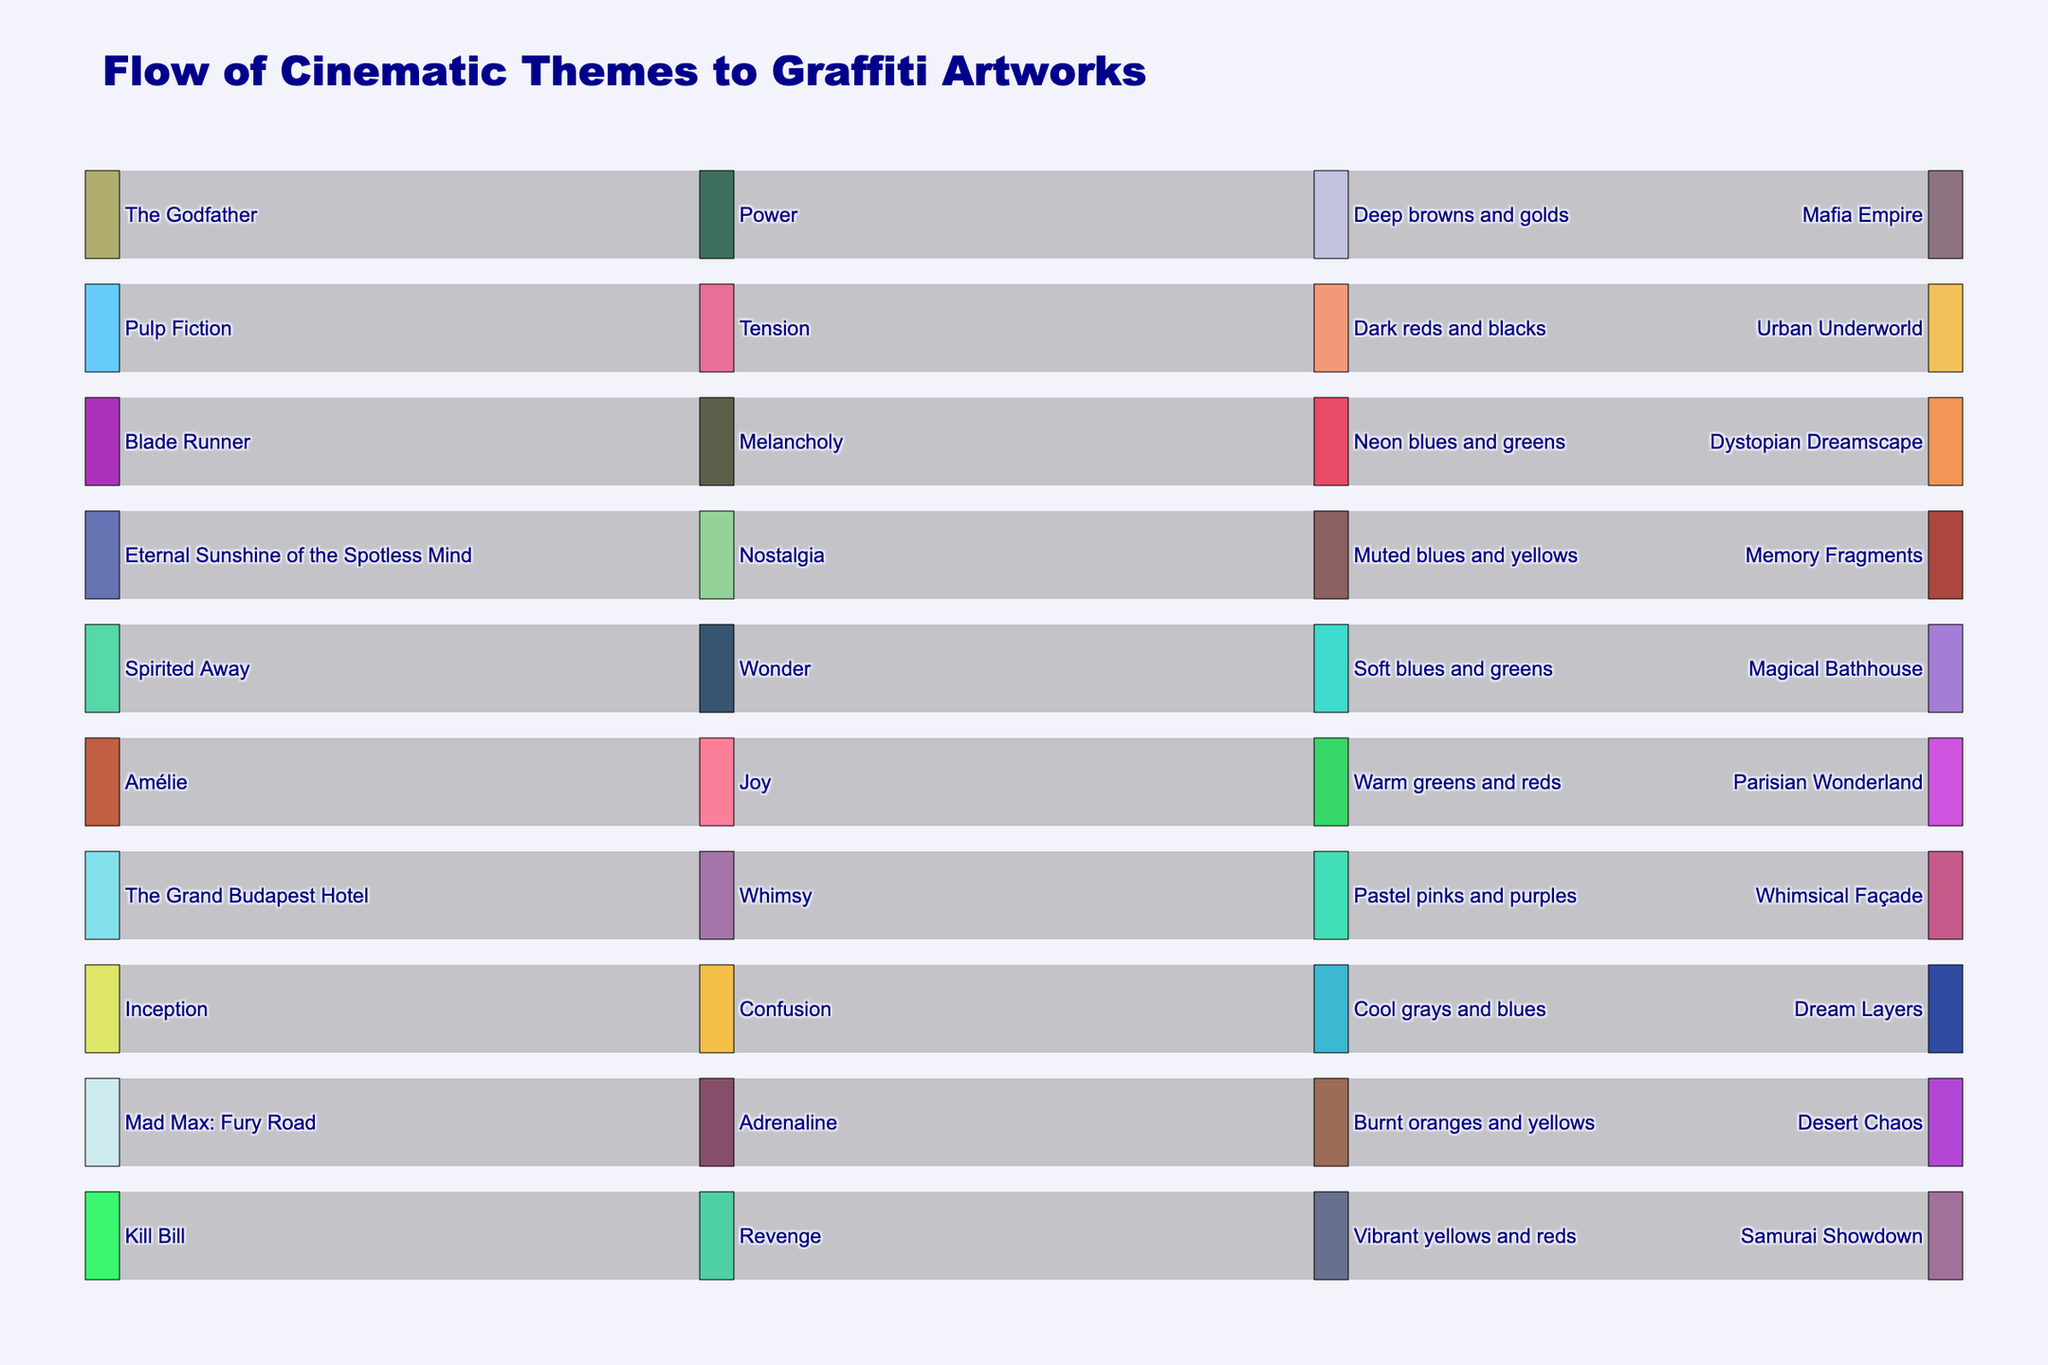Which movie's theme flows into the 'Desert Chaos' graffiti artwork? To determine which movie's theme flows into 'Desert Chaos,' follow the connection from the source movie names. 'Mad Max: Fury Road' flows into 'Adrenaline' and 'Burnt oranges and yellows' before reaching 'Desert Chaos'.
Answer: Mad Max: Fury Road What is the color palette for the graffiti artwork "Urban Underworld"? Trace the flow from the artwork 'Urban Underworld' backward. The color palette before it is 'Dark reds and blacks'.
Answer: Dark reds and blacks How many different emotions are represented in the Sankey diagram? To count the distinct emotions, list all the unique labels in the 'Emotion' category: Tension, Whimsy, Melancholy, Adrenaline, Joy, Power, Nostalgia, Wonder, Confusion, and Revenge, which totals to 10.
Answer: 10 Which movie evokes the emotion of 'Wonder'? Follow the connection from the emotion 'Wonder' backward to the source movie. 'Spirited Away' is linked to 'Wonder'.
Answer: Spirited Away Which color palettes are linked to emotions of 'Melancholy' and 'Joy'? Locate 'Melancholy' and 'Joy' and trace their connections to the color palettes. 'Melancholy' is connected to 'Neon blues and greens', and 'Joy' is connected to 'Warm greens and reds'.
Answer: Neon blues and greens and Warm greens and reds Which emotion eventually leads to the 'Memory Fragments' graffiti artwork? Trace backward from 'Memory Fragments' to the connected emotion. The emotional path leads to 'Nostalgia'.
Answer: Nostalgia Compare the color palettes used in 'Samurai Showdown' and 'Whimsical Façade'. Which one uses more vibrant colors? By examining the color palettes, 'Samurai Showdown' uses 'Vibrant yellows and reds', while 'Whimsical Façade' uses 'Pastel pinks and purples'. The term 'vibrant' indicates stronger, more vivid colors found in 'Vibrant yellows and reds'.
Answer: Samurai Showdown What is the dominant emotion portrayed by the artworks with dark color palettes? Identify the artworks with 'dark' in their color palettes and trace them to the associated emotions. 'Dark reds and blacks' is tied to 'Tension'.
Answer: Tension 